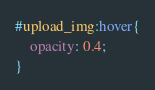<code> <loc_0><loc_0><loc_500><loc_500><_CSS_>#upload_img:hover{
	opacity: 0.4;
}</code> 